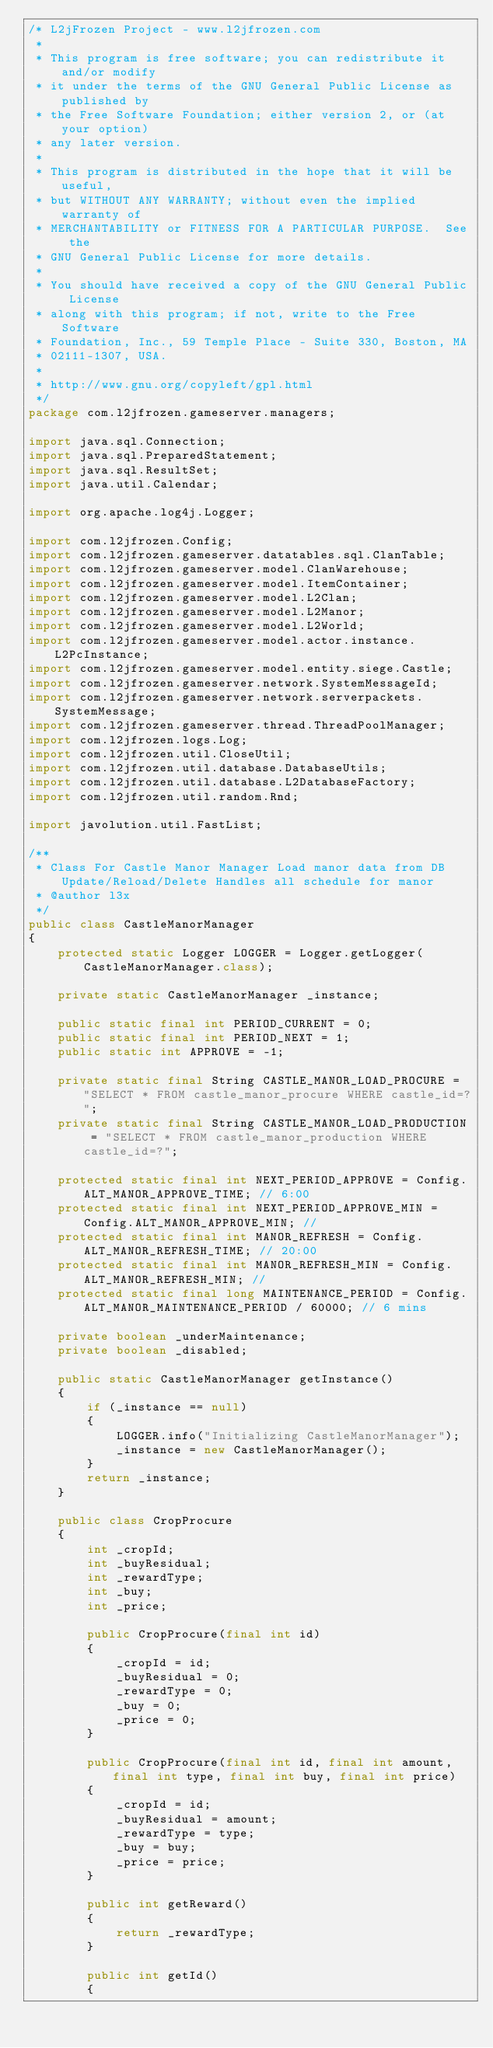<code> <loc_0><loc_0><loc_500><loc_500><_Java_>/* L2jFrozen Project - www.l2jfrozen.com 
 * 
 * This program is free software; you can redistribute it and/or modify
 * it under the terms of the GNU General Public License as published by
 * the Free Software Foundation; either version 2, or (at your option)
 * any later version.
 *
 * This program is distributed in the hope that it will be useful,
 * but WITHOUT ANY WARRANTY; without even the implied warranty of
 * MERCHANTABILITY or FITNESS FOR A PARTICULAR PURPOSE.  See the
 * GNU General Public License for more details.
 *
 * You should have received a copy of the GNU General Public License
 * along with this program; if not, write to the Free Software
 * Foundation, Inc., 59 Temple Place - Suite 330, Boston, MA
 * 02111-1307, USA.
 *
 * http://www.gnu.org/copyleft/gpl.html
 */
package com.l2jfrozen.gameserver.managers;

import java.sql.Connection;
import java.sql.PreparedStatement;
import java.sql.ResultSet;
import java.util.Calendar;

import org.apache.log4j.Logger;

import com.l2jfrozen.Config;
import com.l2jfrozen.gameserver.datatables.sql.ClanTable;
import com.l2jfrozen.gameserver.model.ClanWarehouse;
import com.l2jfrozen.gameserver.model.ItemContainer;
import com.l2jfrozen.gameserver.model.L2Clan;
import com.l2jfrozen.gameserver.model.L2Manor;
import com.l2jfrozen.gameserver.model.L2World;
import com.l2jfrozen.gameserver.model.actor.instance.L2PcInstance;
import com.l2jfrozen.gameserver.model.entity.siege.Castle;
import com.l2jfrozen.gameserver.network.SystemMessageId;
import com.l2jfrozen.gameserver.network.serverpackets.SystemMessage;
import com.l2jfrozen.gameserver.thread.ThreadPoolManager;
import com.l2jfrozen.logs.Log;
import com.l2jfrozen.util.CloseUtil;
import com.l2jfrozen.util.database.DatabaseUtils;
import com.l2jfrozen.util.database.L2DatabaseFactory;
import com.l2jfrozen.util.random.Rnd;

import javolution.util.FastList;

/**
 * Class For Castle Manor Manager Load manor data from DB Update/Reload/Delete Handles all schedule for manor
 * @author l3x
 */
public class CastleManorManager
{
	protected static Logger LOGGER = Logger.getLogger(CastleManorManager.class);
	
	private static CastleManorManager _instance;
	
	public static final int PERIOD_CURRENT = 0;
	public static final int PERIOD_NEXT = 1;
	public static int APPROVE = -1;
	
	private static final String CASTLE_MANOR_LOAD_PROCURE = "SELECT * FROM castle_manor_procure WHERE castle_id=?";
	private static final String CASTLE_MANOR_LOAD_PRODUCTION = "SELECT * FROM castle_manor_production WHERE castle_id=?";
	
	protected static final int NEXT_PERIOD_APPROVE = Config.ALT_MANOR_APPROVE_TIME; // 6:00
	protected static final int NEXT_PERIOD_APPROVE_MIN = Config.ALT_MANOR_APPROVE_MIN; //
	protected static final int MANOR_REFRESH = Config.ALT_MANOR_REFRESH_TIME; // 20:00
	protected static final int MANOR_REFRESH_MIN = Config.ALT_MANOR_REFRESH_MIN; //
	protected static final long MAINTENANCE_PERIOD = Config.ALT_MANOR_MAINTENANCE_PERIOD / 60000; // 6 mins
	
	private boolean _underMaintenance;
	private boolean _disabled;
	
	public static CastleManorManager getInstance()
	{
		if (_instance == null)
		{
			LOGGER.info("Initializing CastleManorManager");
			_instance = new CastleManorManager();
		}
		return _instance;
	}
	
	public class CropProcure
	{
		int _cropId;
		int _buyResidual;
		int _rewardType;
		int _buy;
		int _price;
		
		public CropProcure(final int id)
		{
			_cropId = id;
			_buyResidual = 0;
			_rewardType = 0;
			_buy = 0;
			_price = 0;
		}
		
		public CropProcure(final int id, final int amount, final int type, final int buy, final int price)
		{
			_cropId = id;
			_buyResidual = amount;
			_rewardType = type;
			_buy = buy;
			_price = price;
		}
		
		public int getReward()
		{
			return _rewardType;
		}
		
		public int getId()
		{</code> 